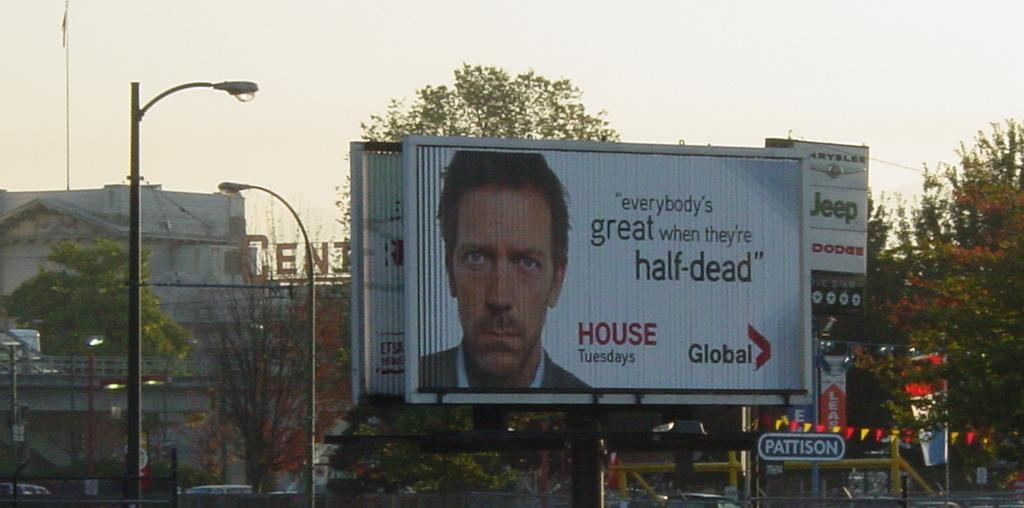<image>
Render a clear and concise summary of the photo. The show advertised on the billboard is shown on Tuesdays. 